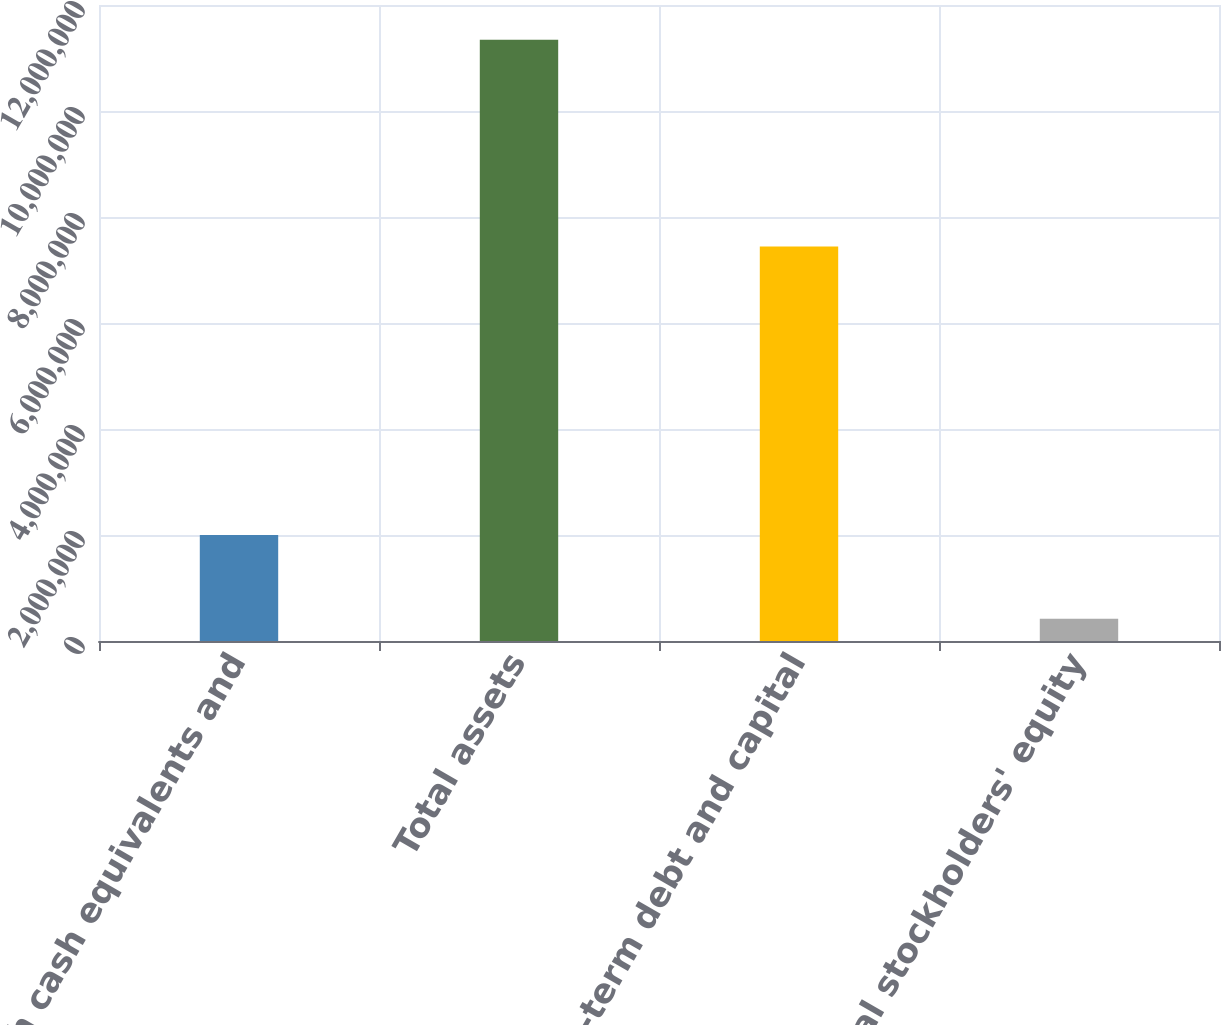Convert chart to OTSL. <chart><loc_0><loc_0><loc_500><loc_500><bar_chart><fcel>Cash cash equivalents and<fcel>Total assets<fcel>Long-term debt and capital<fcel>Total stockholders' equity<nl><fcel>2.00192e+06<fcel>1.13461e+07<fcel>7.44162e+06<fcel>419003<nl></chart> 